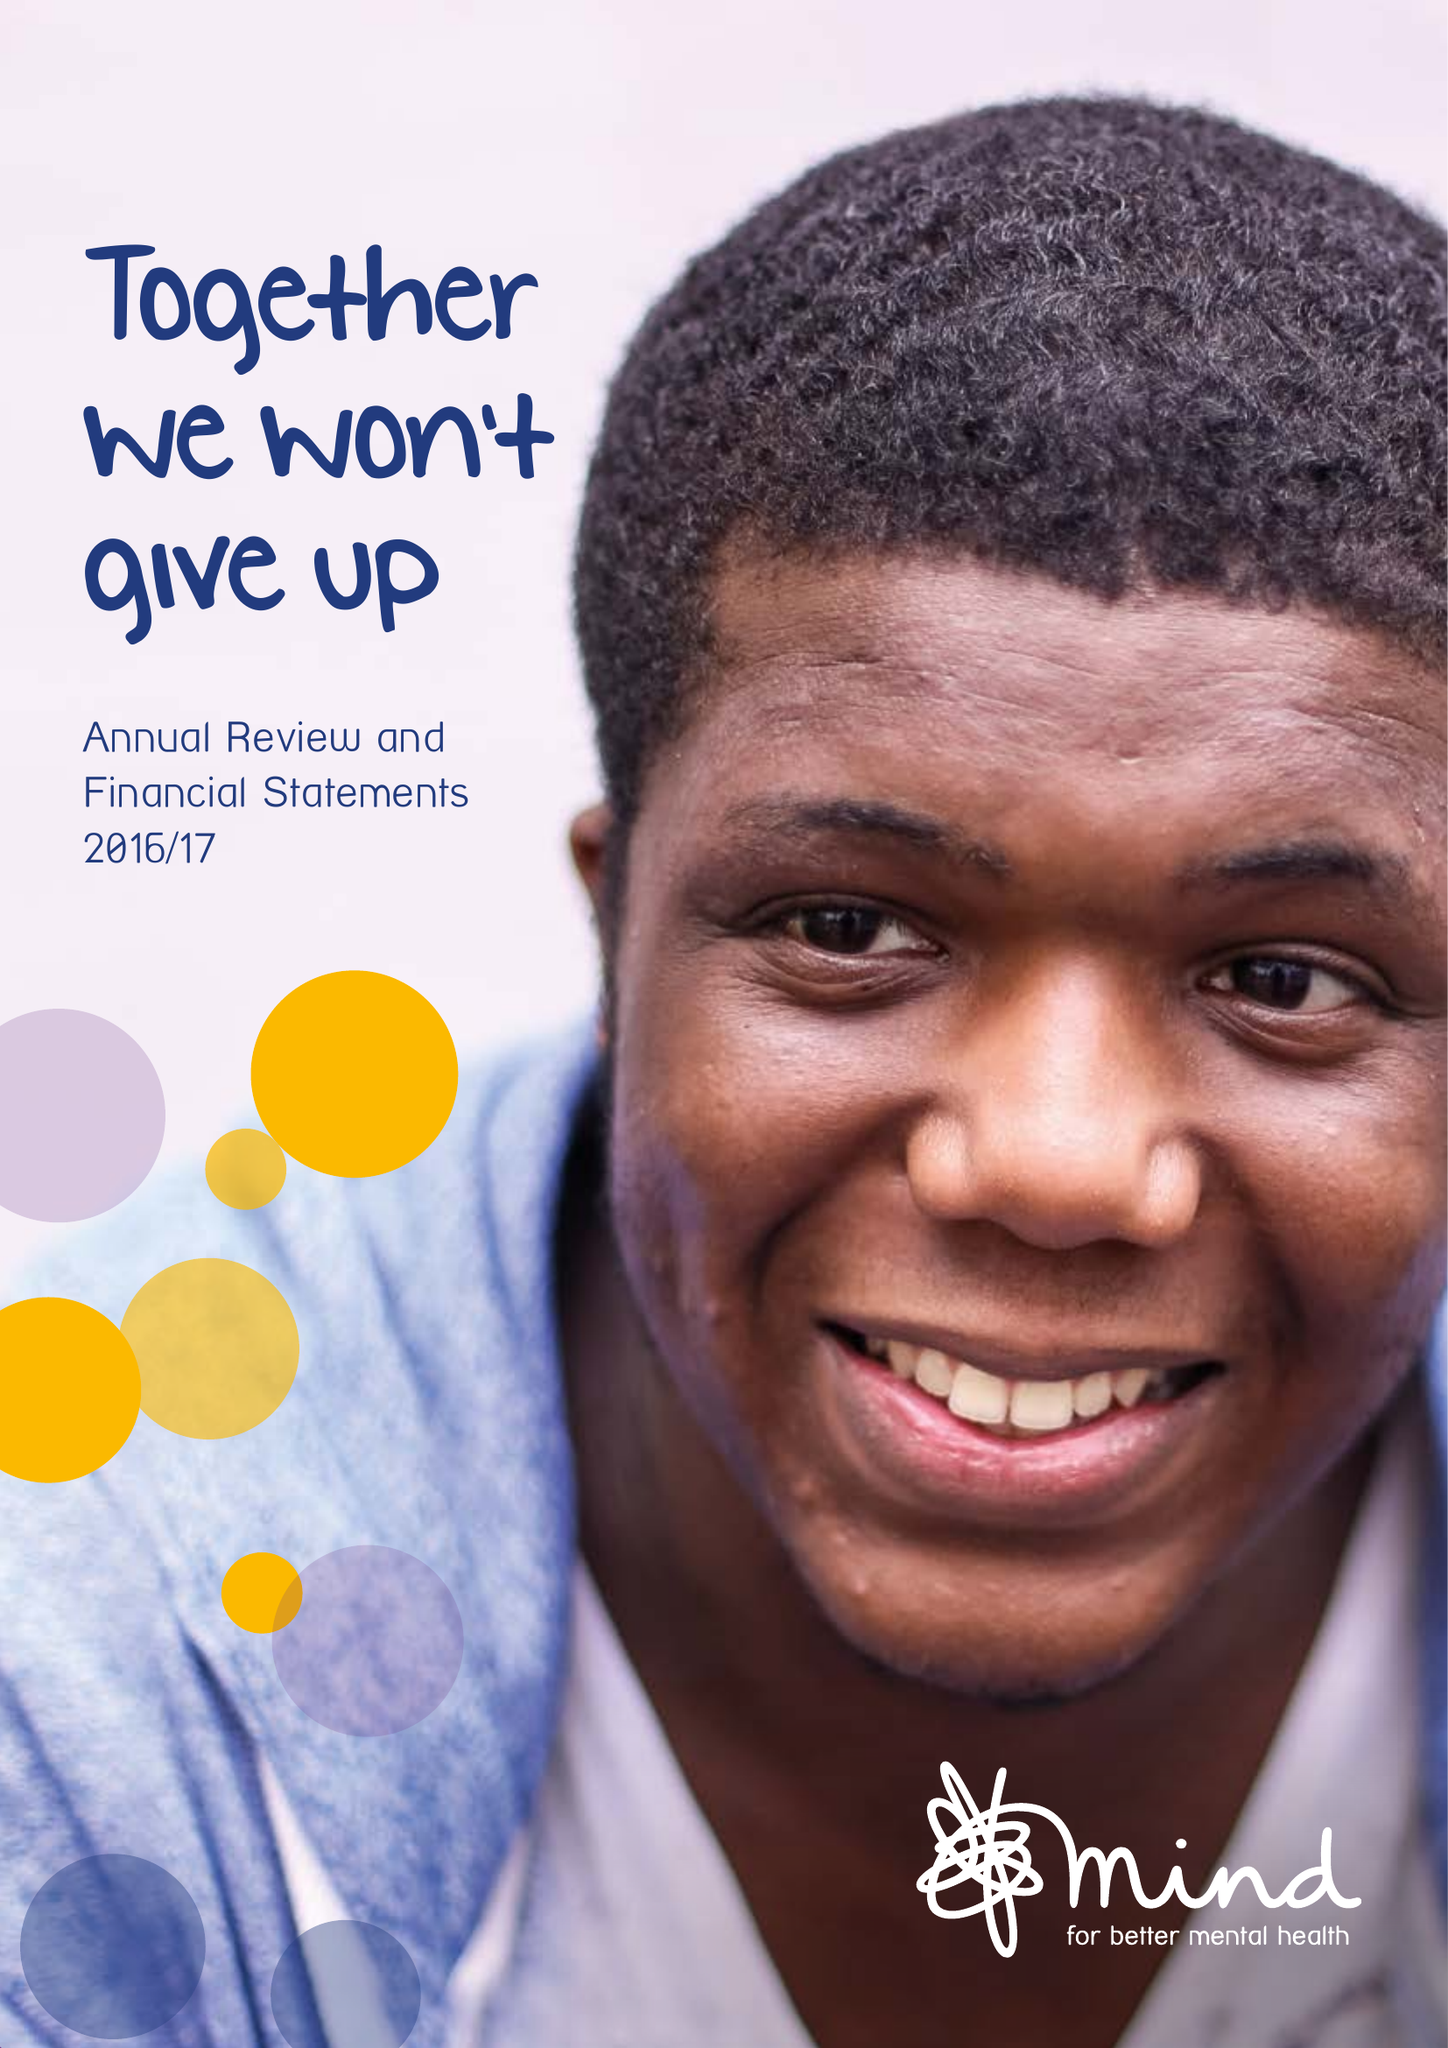What is the value for the spending_annually_in_british_pounds?
Answer the question using a single word or phrase. 38244000.00 